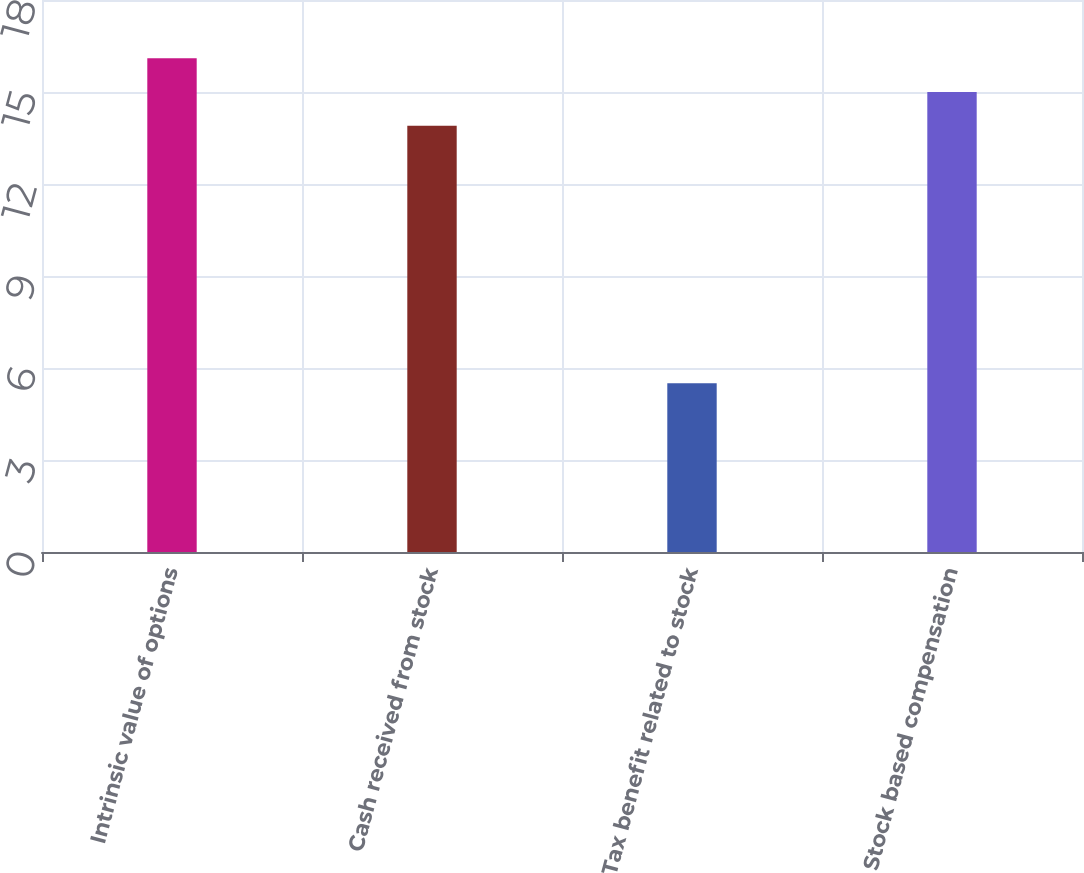<chart> <loc_0><loc_0><loc_500><loc_500><bar_chart><fcel>Intrinsic value of options<fcel>Cash received from stock<fcel>Tax benefit related to stock<fcel>Stock based compensation<nl><fcel>16.1<fcel>13.9<fcel>5.5<fcel>15<nl></chart> 